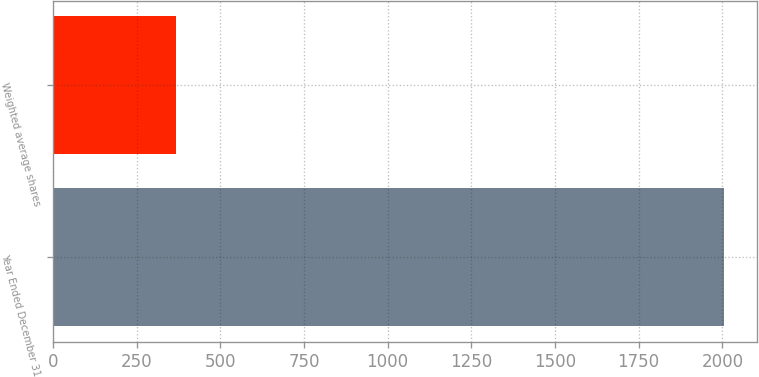Convert chart to OTSL. <chart><loc_0><loc_0><loc_500><loc_500><bar_chart><fcel>Year Ended December 31<fcel>Weighted average shares<nl><fcel>2004<fcel>367.35<nl></chart> 